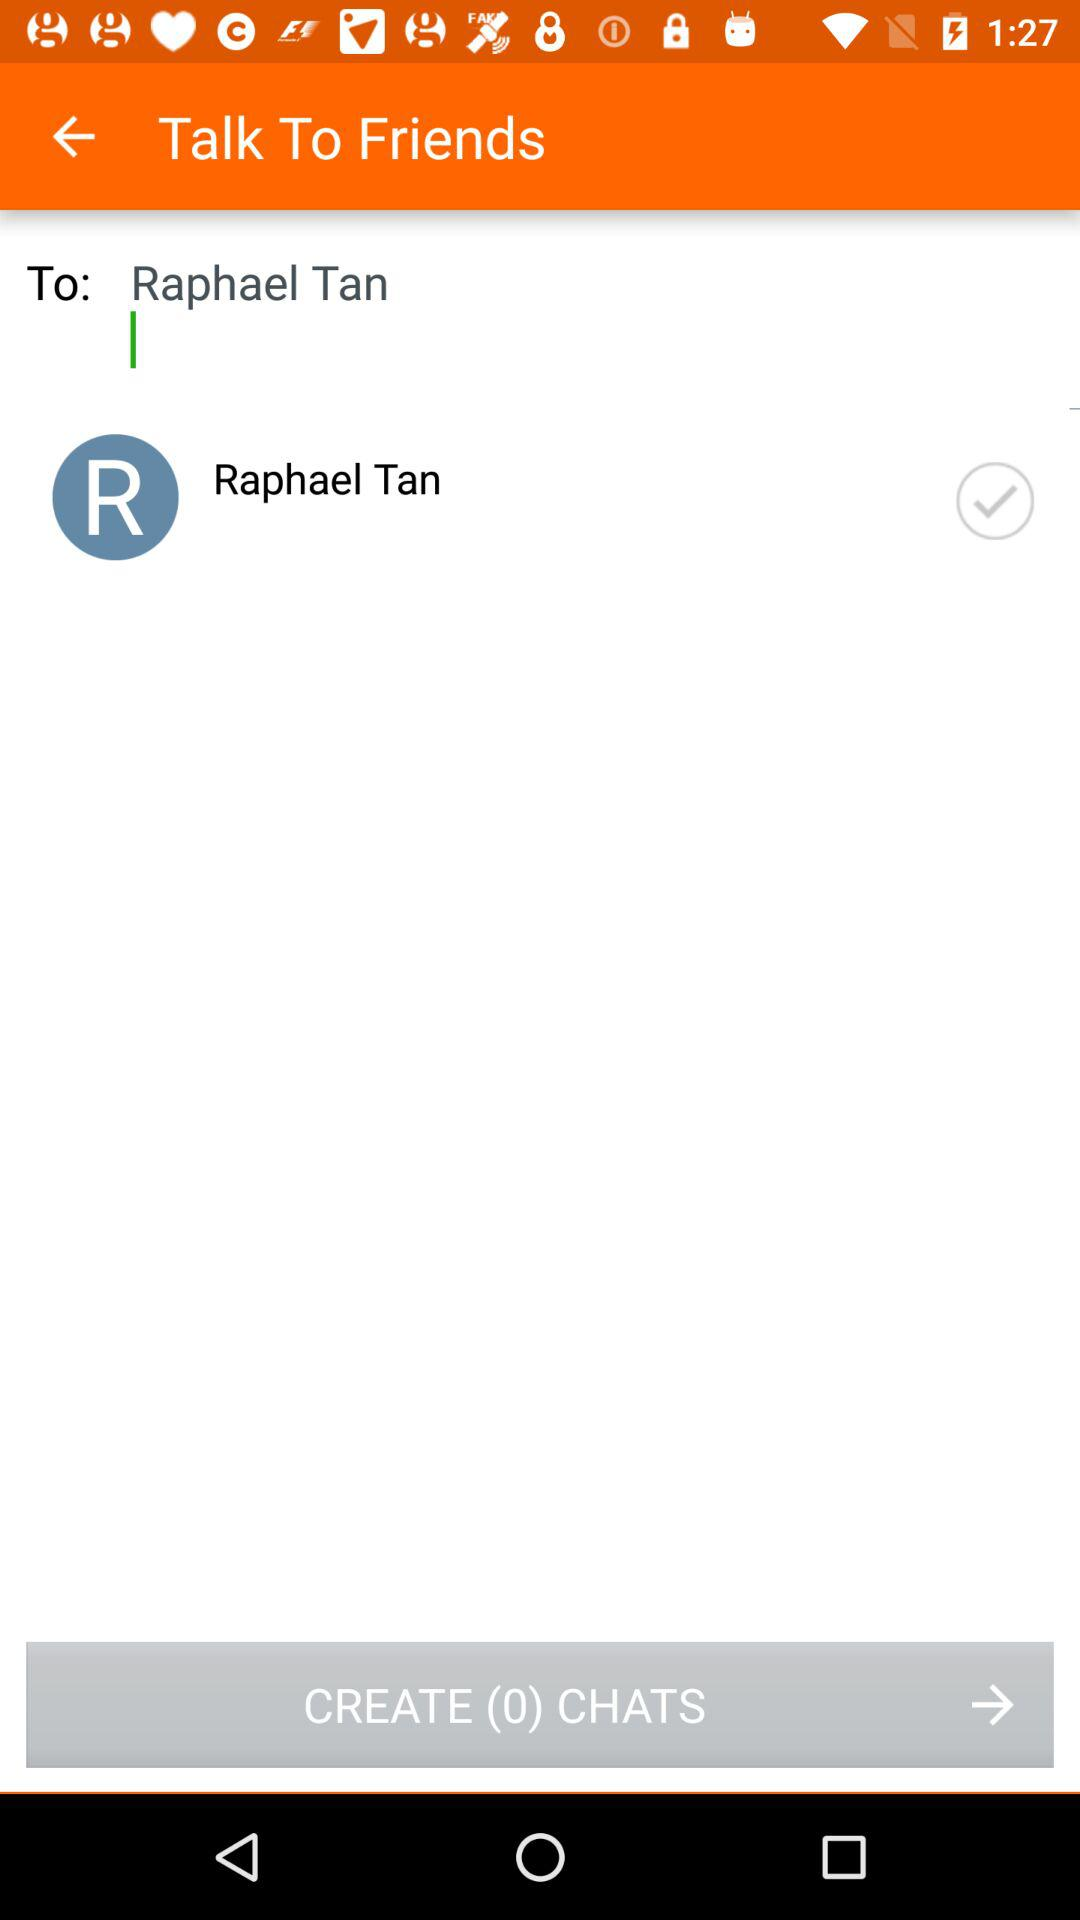What is the name of the friend I am talking to? The name of the friend is Raphael Tan. 